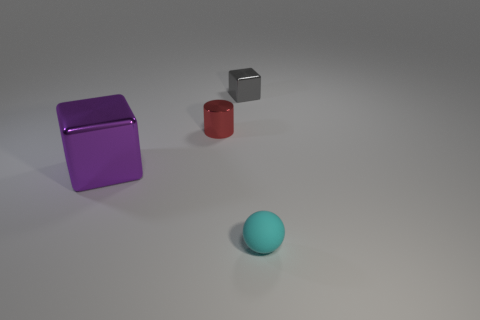Add 4 large brown things. How many objects exist? 8 Subtract all cylinders. How many objects are left? 3 Subtract all small purple cylinders. Subtract all red metal objects. How many objects are left? 3 Add 2 tiny cyan things. How many tiny cyan things are left? 3 Add 3 matte balls. How many matte balls exist? 4 Subtract 0 gray balls. How many objects are left? 4 Subtract 1 balls. How many balls are left? 0 Subtract all green balls. Subtract all purple cubes. How many balls are left? 1 